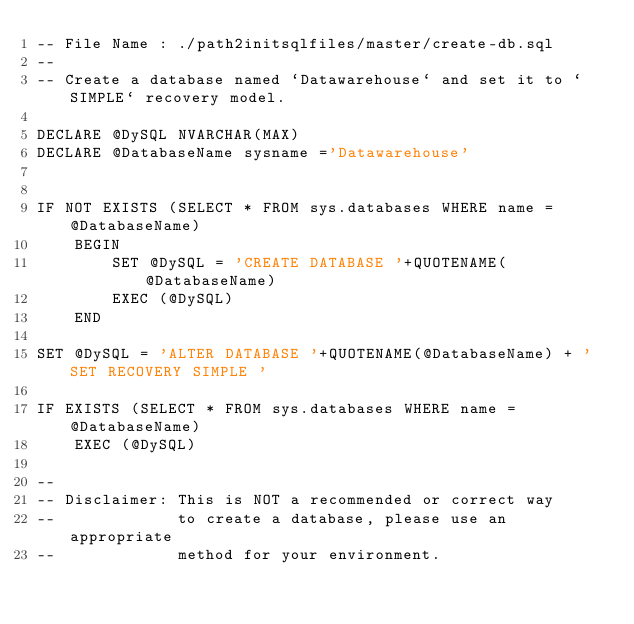Convert code to text. <code><loc_0><loc_0><loc_500><loc_500><_SQL_>-- File Name : ./path2initsqlfiles/master/create-db.sql
--       
-- Create a database named `Datawarehouse` and set it to `SIMPLE` recovery model.

DECLARE @DySQL NVARCHAR(MAX) 
DECLARE @DatabaseName sysname ='Datawarehouse'


IF NOT EXISTS (SELECT * FROM sys.databases WHERE name = @DatabaseName)
    BEGIN
        SET @DySQL = 'CREATE DATABASE '+QUOTENAME(@DatabaseName)
        EXEC (@DySQL)
    END

SET @DySQL = 'ALTER DATABASE '+QUOTENAME(@DatabaseName) + ' SET RECOVERY SIMPLE '

IF EXISTS (SELECT * FROM sys.databases WHERE name = @DatabaseName)
    EXEC (@DySQL)

--
-- Disclaimer: This is NOT a recommended or correct way 
--             to create a database, please use an appropriate
--             method for your environment.

</code> 